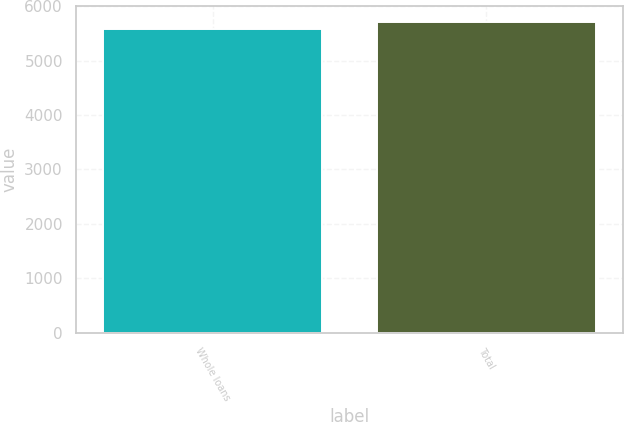<chart> <loc_0><loc_0><loc_500><loc_500><bar_chart><fcel>Whole loans<fcel>Total<nl><fcel>5580<fcel>5716<nl></chart> 